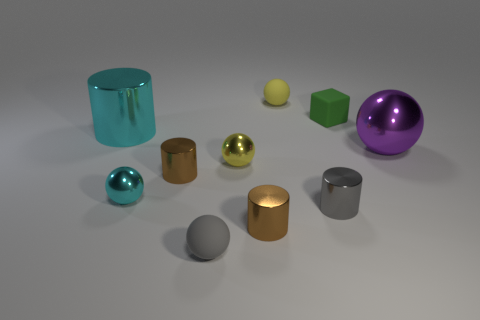There is a object that is the same color as the large cylinder; what size is it?
Your answer should be very brief. Small. There is a gray sphere that is the same size as the green rubber object; what material is it?
Your response must be concise. Rubber. There is a brown metallic cylinder right of the small gray rubber object; is it the same size as the matte ball that is behind the tiny gray metal object?
Give a very brief answer. Yes. Is there a large object that has the same material as the big cyan cylinder?
Ensure brevity in your answer.  Yes. What number of things are large purple objects on the right side of the block or small red matte cubes?
Your answer should be compact. 1. Does the large object on the right side of the green rubber cube have the same material as the tiny green thing?
Ensure brevity in your answer.  No. Do the gray metal thing and the big cyan metal thing have the same shape?
Make the answer very short. Yes. There is a matte thing left of the small yellow shiny thing; how many tiny gray things are behind it?
Make the answer very short. 1. There is a tiny gray thing that is the same shape as the large cyan thing; what material is it?
Provide a short and direct response. Metal. There is a tiny shiny ball that is to the left of the gray ball; does it have the same color as the large cylinder?
Your answer should be very brief. Yes. 